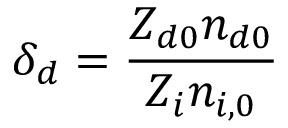Convert formula to latex. <formula><loc_0><loc_0><loc_500><loc_500>\delta _ { d } = \frac { Z _ { d 0 } n _ { d 0 } } { Z _ { i } n _ { i , 0 } }</formula> 